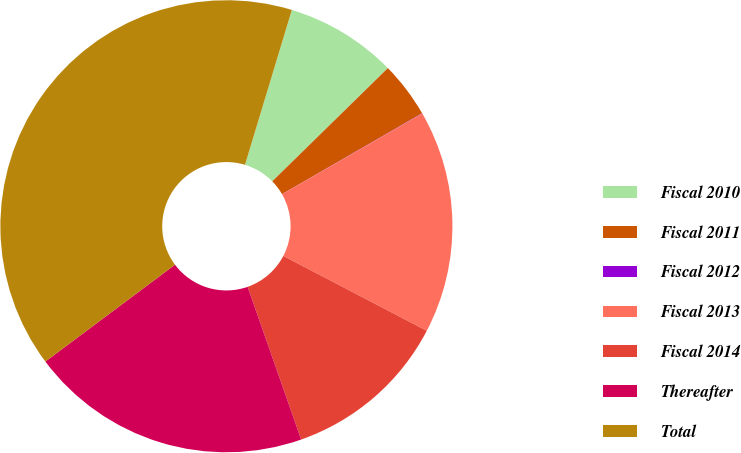<chart> <loc_0><loc_0><loc_500><loc_500><pie_chart><fcel>Fiscal 2010<fcel>Fiscal 2011<fcel>Fiscal 2012<fcel>Fiscal 2013<fcel>Fiscal 2014<fcel>Thereafter<fcel>Total<nl><fcel>7.99%<fcel>4.0%<fcel>0.02%<fcel>15.97%<fcel>11.98%<fcel>20.15%<fcel>39.89%<nl></chart> 